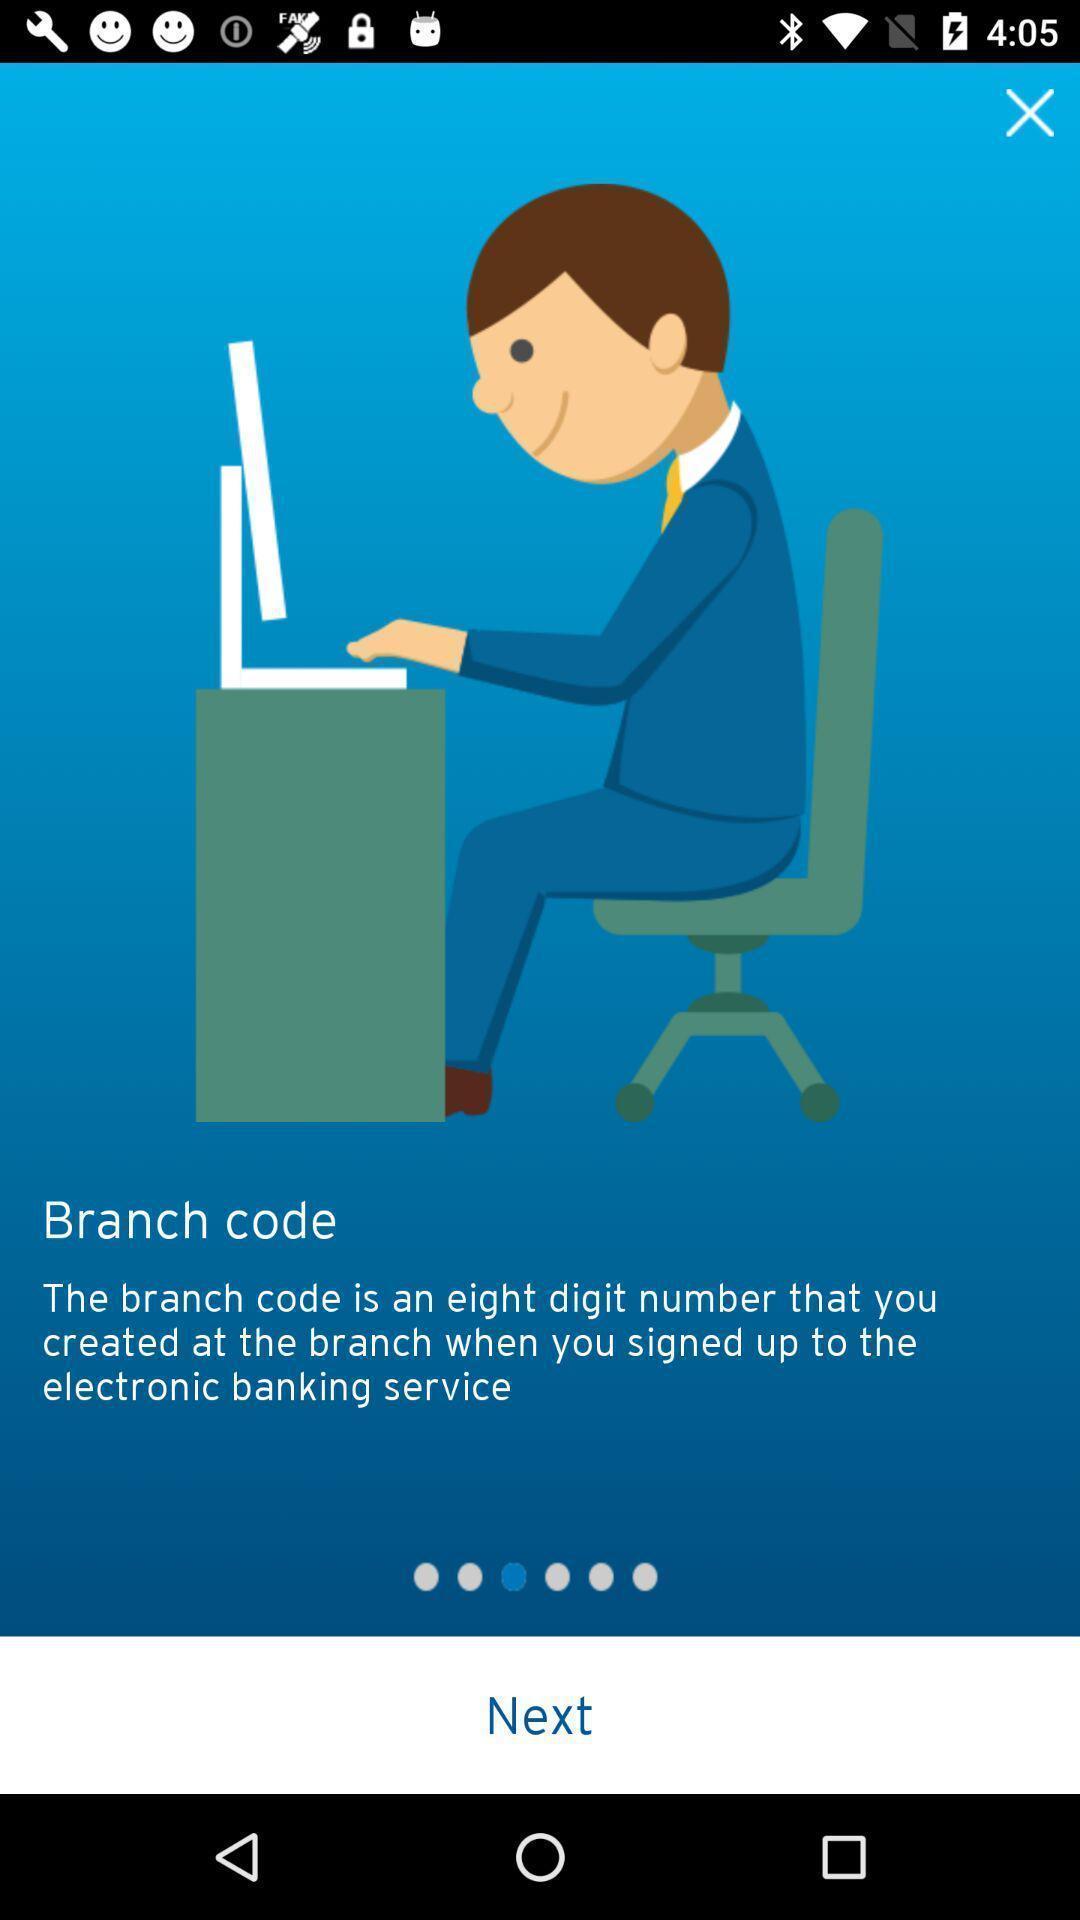What is the overall content of this screenshot? Welcome page for a banking app. 